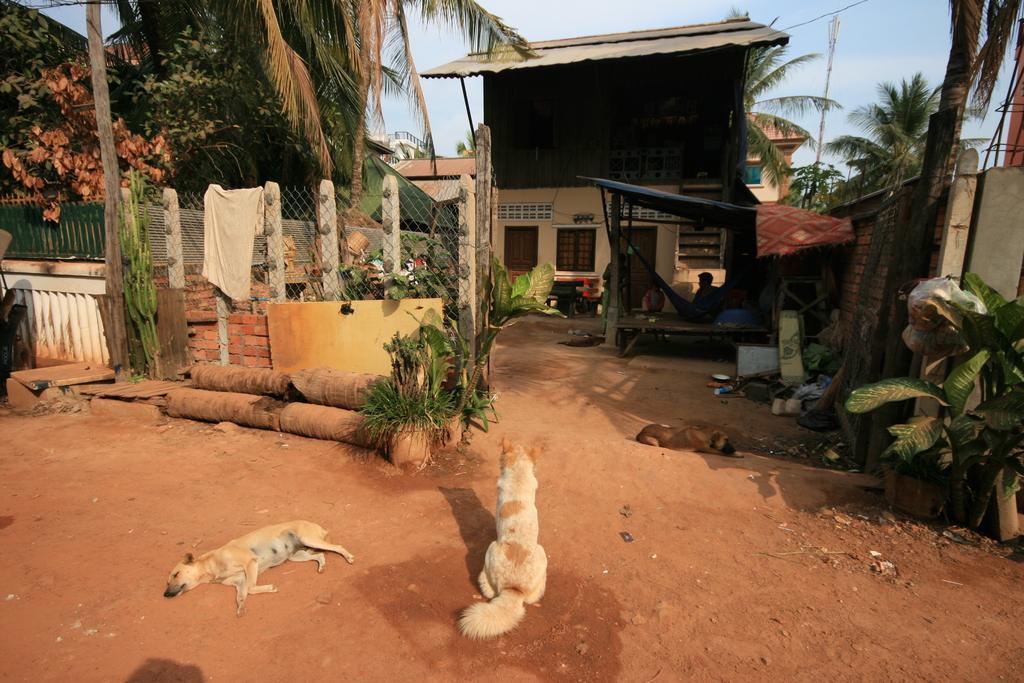In one or two sentences, can you explain what this image depicts? In this image I can see three dogs on the road. In the background I can see house plants, tree trunks, fence, tents, houses, trees, vehicles, two persons, light poles, some objects and the sky. This image is taken may be during a day. 